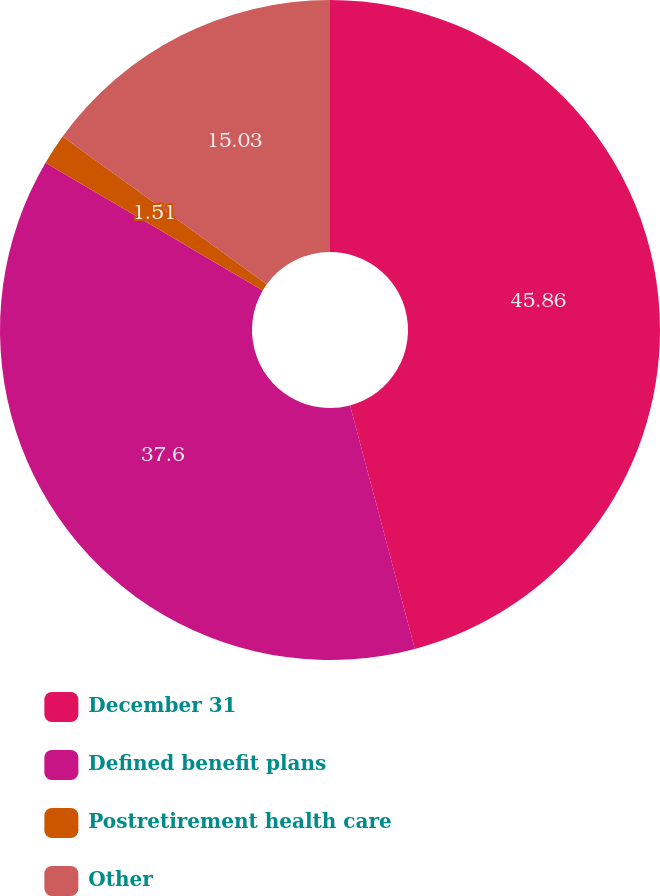Convert chart to OTSL. <chart><loc_0><loc_0><loc_500><loc_500><pie_chart><fcel>December 31<fcel>Defined benefit plans<fcel>Postretirement health care<fcel>Other<nl><fcel>45.86%<fcel>37.6%<fcel>1.51%<fcel>15.03%<nl></chart> 